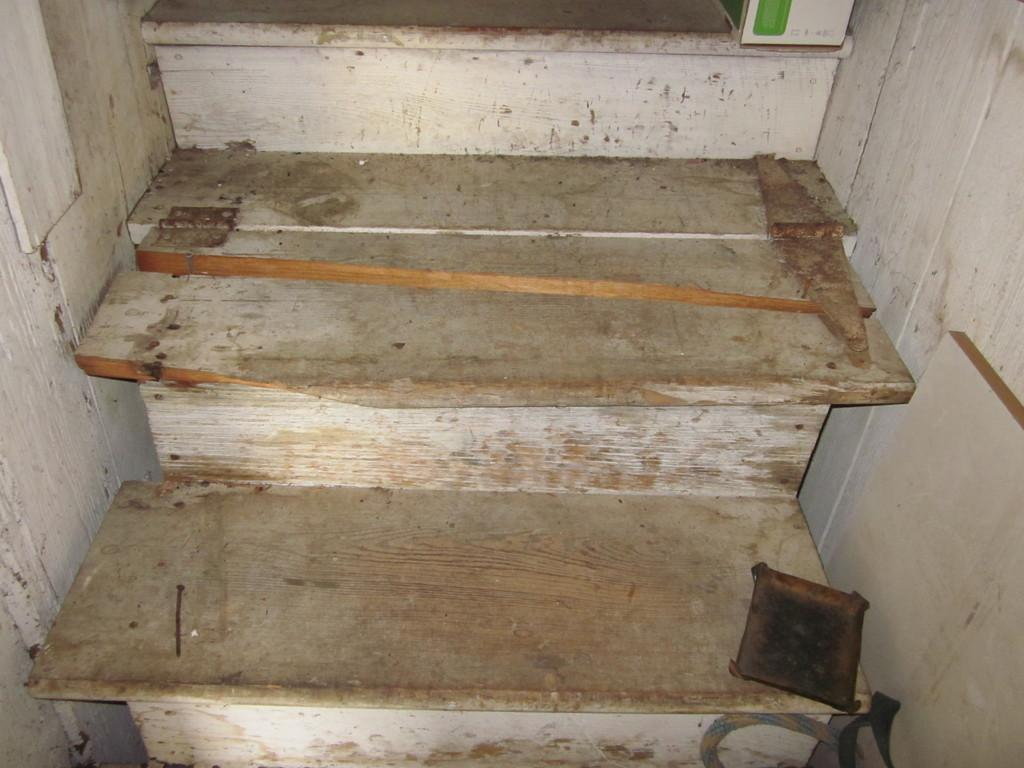What type of structure is present in the image? There are stairs in the image. What is the material of the object located near the stairs? There is an iron nail in the image. Can you describe any other items visible in the image? There are other unspecified items in the image. How much sugar is present in the image? There is no mention of sugar in the image, so it cannot be determined how much is present. Is there any jam visible in the image? There is no mention of jam in the image, so it cannot be determined if it is present. 